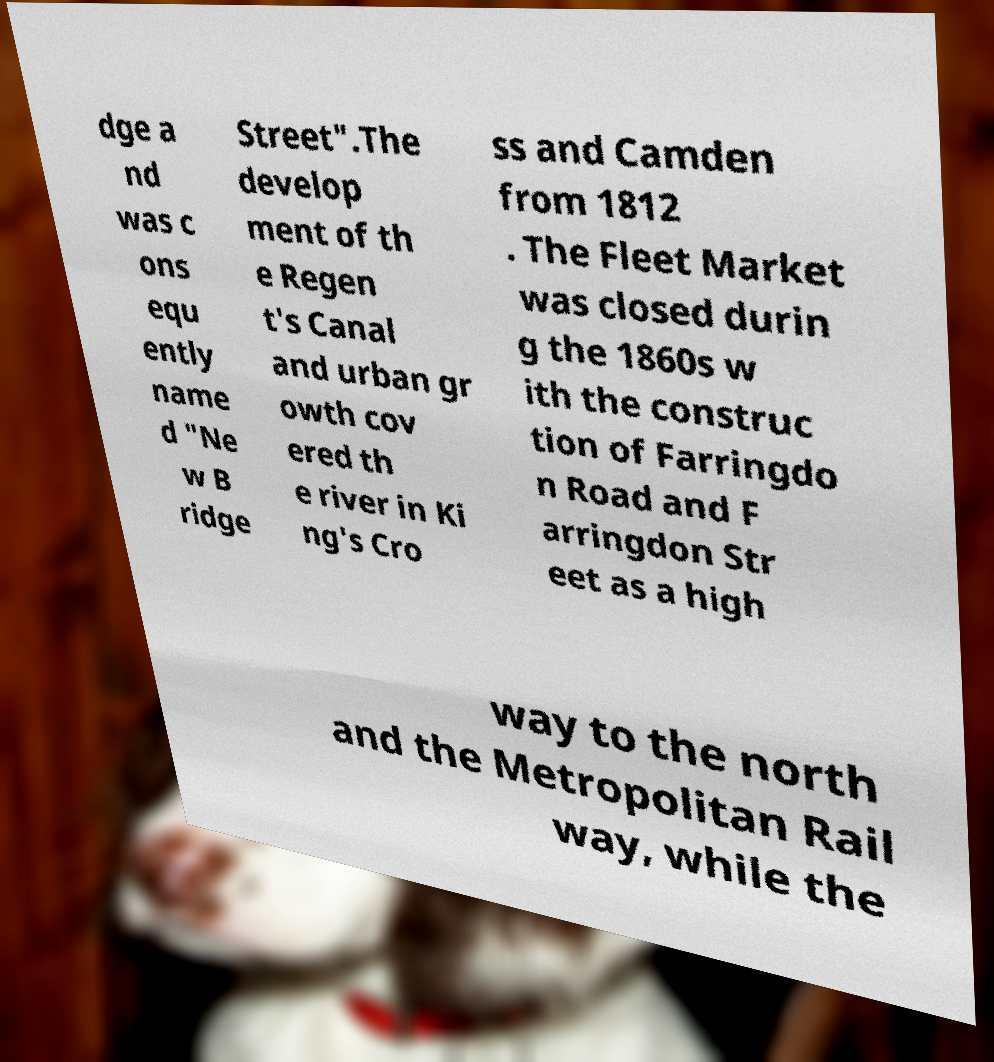I need the written content from this picture converted into text. Can you do that? dge a nd was c ons equ ently name d "Ne w B ridge Street".The develop ment of th e Regen t's Canal and urban gr owth cov ered th e river in Ki ng's Cro ss and Camden from 1812 . The Fleet Market was closed durin g the 1860s w ith the construc tion of Farringdo n Road and F arringdon Str eet as a high way to the north and the Metropolitan Rail way, while the 